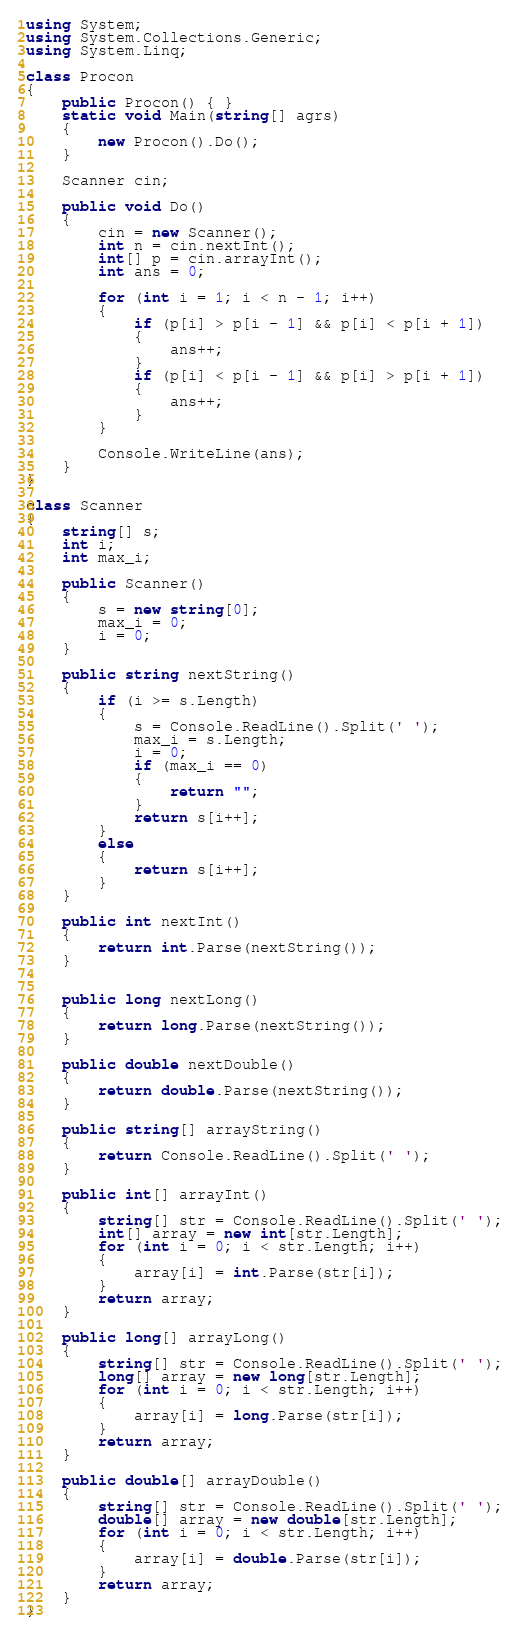Convert code to text. <code><loc_0><loc_0><loc_500><loc_500><_C#_>using System;
using System.Collections.Generic;
using System.Linq;

class Procon
{
    public Procon() { }
    static void Main(string[] agrs)
    {
        new Procon().Do();
    }

    Scanner cin;

    public void Do()
    {
        cin = new Scanner();
        int n = cin.nextInt();
        int[] p = cin.arrayInt();
        int ans = 0;

        for (int i = 1; i < n - 1; i++)
        {
            if (p[i] > p[i - 1] && p[i] < p[i + 1])
            {
                ans++;
            }
            if (p[i] < p[i - 1] && p[i] > p[i + 1])
            {
                ans++;
            }
        }

        Console.WriteLine(ans);
    }
}

class Scanner
{
    string[] s;
    int i;
    int max_i;

    public Scanner()
    {
        s = new string[0];
        max_i = 0;
        i = 0;
    }

    public string nextString()
    {
        if (i >= s.Length)
        {
            s = Console.ReadLine().Split(' ');
            max_i = s.Length;
            i = 0;
            if (max_i == 0)
            {
                return "";
            }
            return s[i++];
        }
        else
        {
            return s[i++];
        }
    }

    public int nextInt()
    {
        return int.Parse(nextString());
    }


    public long nextLong()
    {
        return long.Parse(nextString());
    }

    public double nextDouble()
    {
        return double.Parse(nextString());
    }

    public string[] arrayString()
    {
        return Console.ReadLine().Split(' ');
    }

    public int[] arrayInt()
    {
        string[] str = Console.ReadLine().Split(' ');
        int[] array = new int[str.Length];
        for (int i = 0; i < str.Length; i++)
        {
            array[i] = int.Parse(str[i]);
        }
        return array;
    }

    public long[] arrayLong()
    {
        string[] str = Console.ReadLine().Split(' ');
        long[] array = new long[str.Length];
        for (int i = 0; i < str.Length; i++)
        {
            array[i] = long.Parse(str[i]);
        }
        return array;
    }

    public double[] arrayDouble()
    {
        string[] str = Console.ReadLine().Split(' ');
        double[] array = new double[str.Length];
        for (int i = 0; i < str.Length; i++)
        {
            array[i] = double.Parse(str[i]);
        }
        return array;
    }
}

</code> 